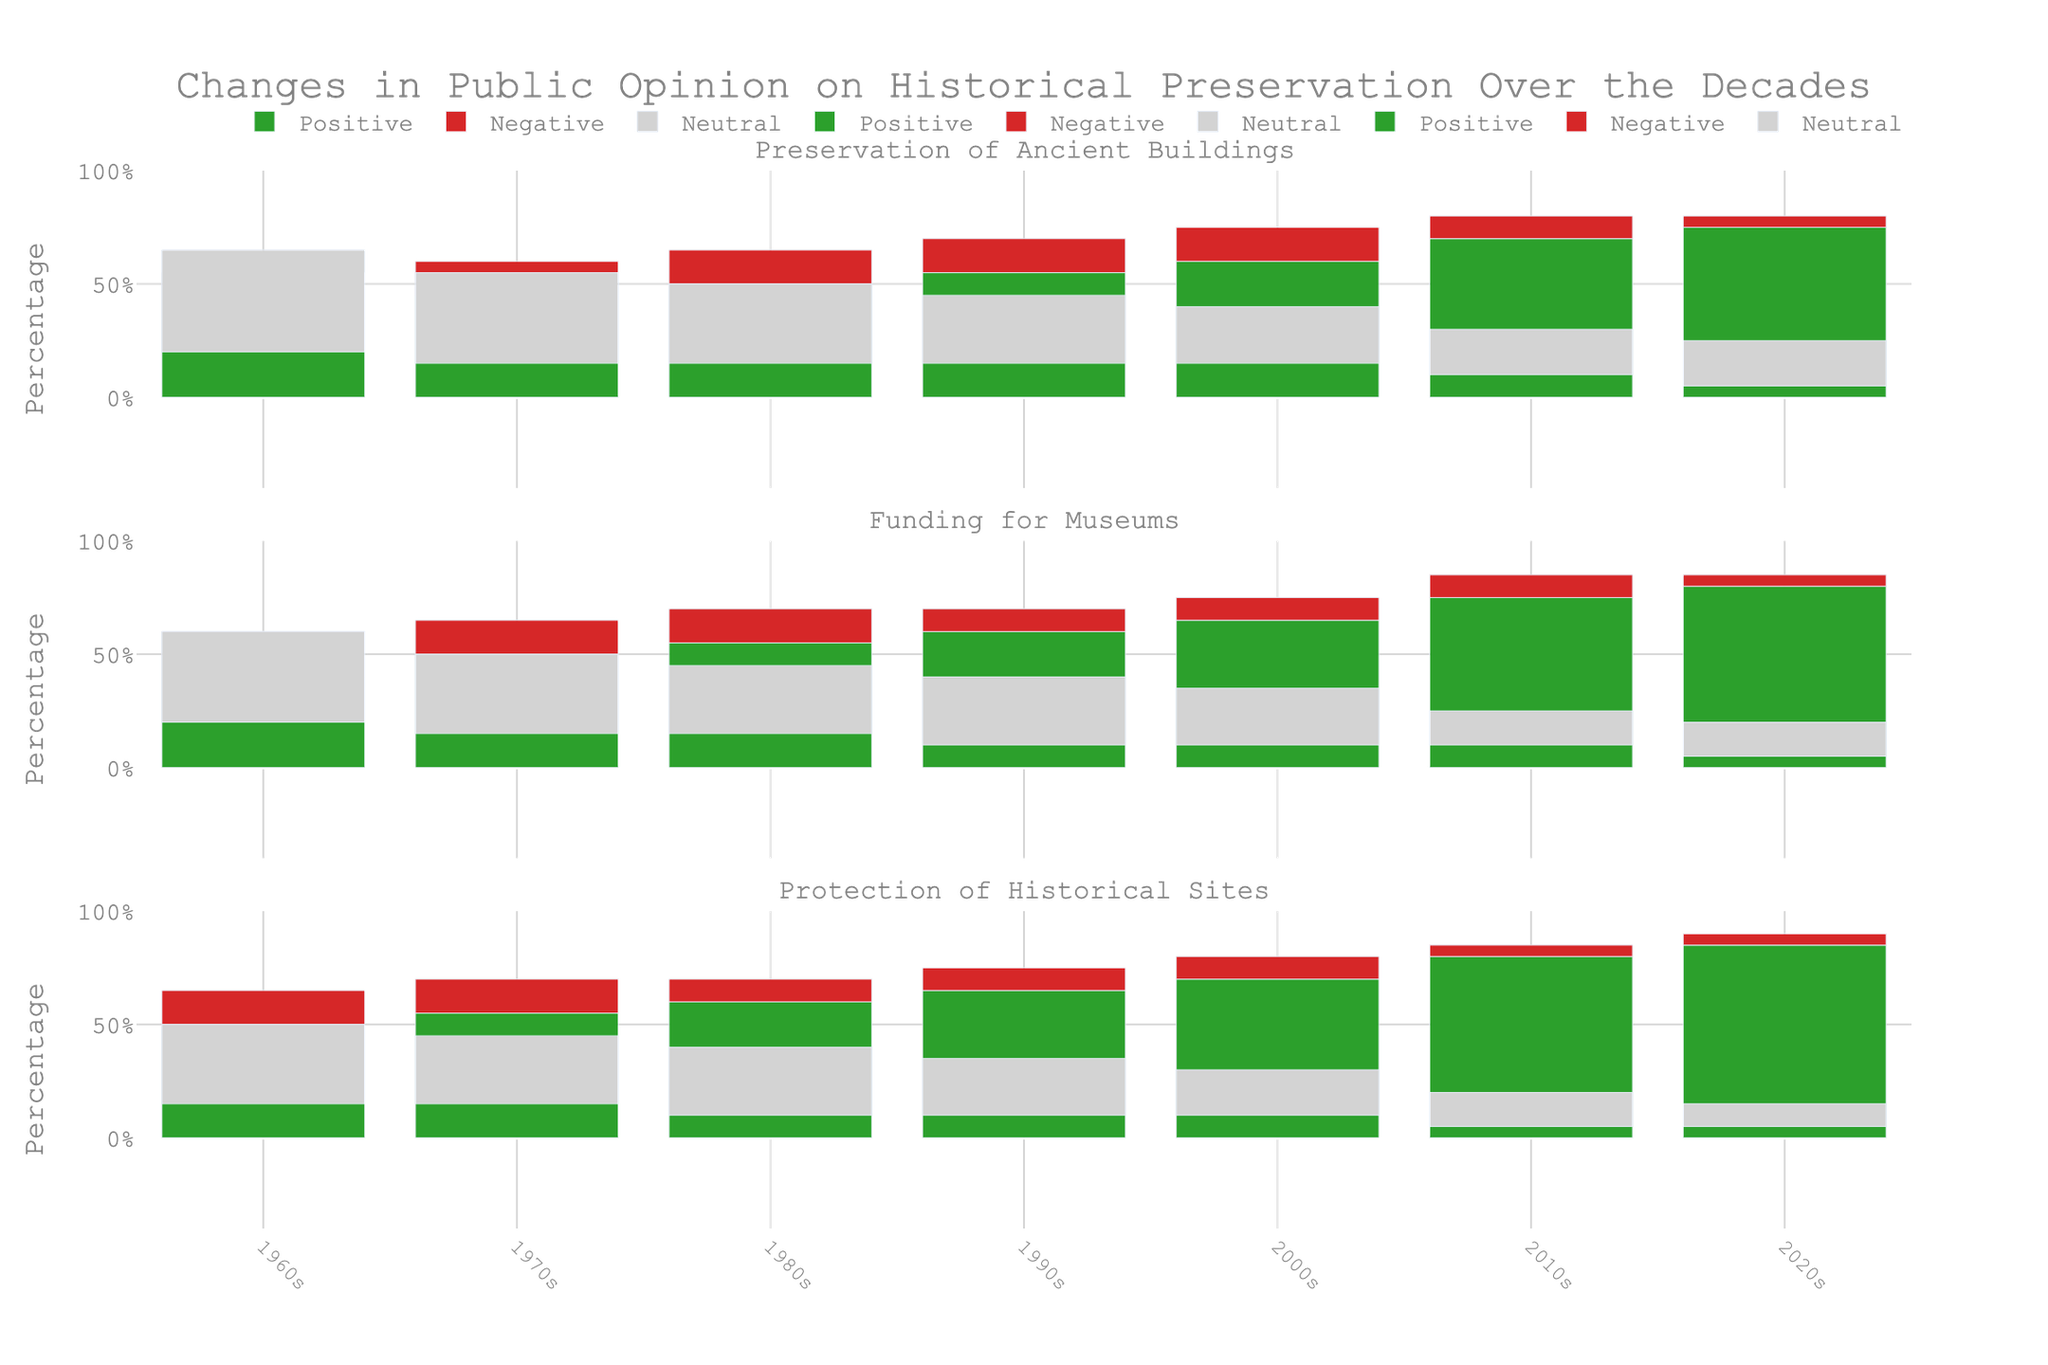What decade had the highest positive sentiment for the Protection of Historical Sites? First, we identify the trace for Protection of Historical Sites. From there, we visually identify the bar with the highest height in the green color category. The 2020s has the highest positive sentiment as the positive bar for that decade is the tallest.
Answer: 2020s What is the trend in negative sentiment for Funding for Museums from the 1960s to the 2020s? To determine the trend, we look at the red bars corresponding to Funding for Museums across all decades. The height of the red bars decreases from 20% in the 1960s to 5% in the 2020s, indicating a decreasing trend in negative sentiment over time.
Answer: Decreasing How does the positive sentiment for Preservation of Ancient Buildings in the 1990s compare to that in the 2000s? Locate the green bars representing Preservation of Ancient Buildings for both decades. In the 1990s, the positive sentiment is represented by a bar with a height of 55%, and in the 2000s, it increases to 60%.
Answer: Higher in the 2000s Which category showed the most significant increase in positive sentiment from the 1960s to the 2020s? Compare the green bars for all categories between the 1960s and 2020s. Calculate the change for each: Preservation of Ancient Buildings (75 - 35 = 40), Funding for Museums (80 - 40 = 40), Protection of Historical Sites (85 - 50 = 35). The Funding for Museums and Preservation of Ancient Buildings both increased by 40%, which is the most significant increase.
Answer: Funding for Museums and Preservation of Ancient Buildings What's the average neutral sentiment for Funding for Museums across all decades? Locate the neutral (gray) bars for Funding for Museums across each decade. The values are 40, 35, 30, 30, 25, 15, and 15. Sum these values and divide by the number of decades, which is 7: (40+35+30+30+25+15+15)/7 = 190/7 ≈ 27.14%.
Answer: 27.14% In which decade was the negative sentiment for Preservation of Ancient Buildings the highest? Observe the red bars for Preservation of Ancient Buildings for each decade. The tallest red bar stands for 1960s, which is 20%.
Answer: 1960s How much did the positive sentiment for Protection of Historical Sites change from the 1970s to the 2010s? Identify the green bars for the Protection of Historical Sites in the 1970s and 2010s. Calculate the difference: 80% (2010s) - 55% (1970s) = 25%.
Answer: 25% What is the total positive sentiment for Preservation of Ancient Buildings across all decades? Sum the green bars' values for Preservation of Ancient Buildings across all decades: 35 + 45 + 50 + 55 + 60 + 70 + 75 = 390.
Answer: 390 What was the difference in neutral sentiment for Protection of Historical Sites between the 1980s and 2020s? Find the gray bars for Protection of Historical Sites in the 1980s and 2020s. Calculate the difference: 30% (1980s) - 10% (2020s) = 20%.
Answer: 20% What percentage of public opinion was negative towards Funding for Museums in the 1960s compared to the 2020s? Look at the red bars for Funding for Museums. The values are 20% for the 1960s and 5% for the 2020s. Subtract the latter from the former: 20% - 5% = 15%.
Answer: 15% 